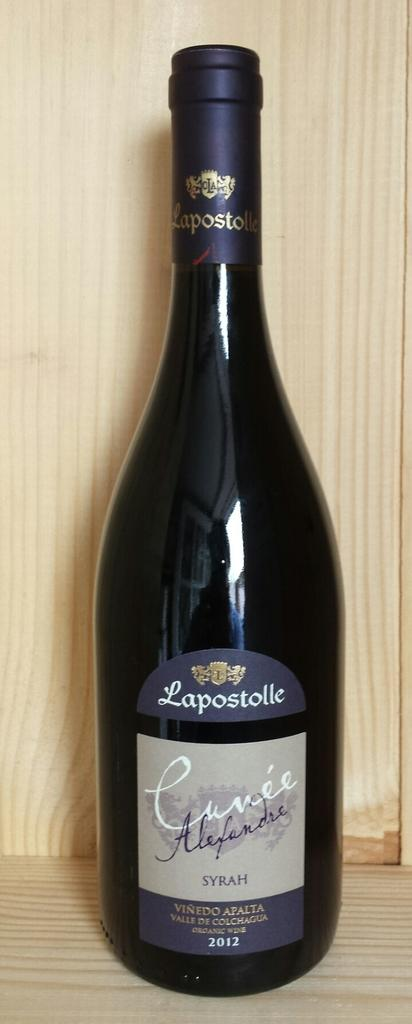<image>
Describe the image concisely. A dark glass bottle of Lapostolle Cuvee Alexandre sitting on a wooden shelf. 